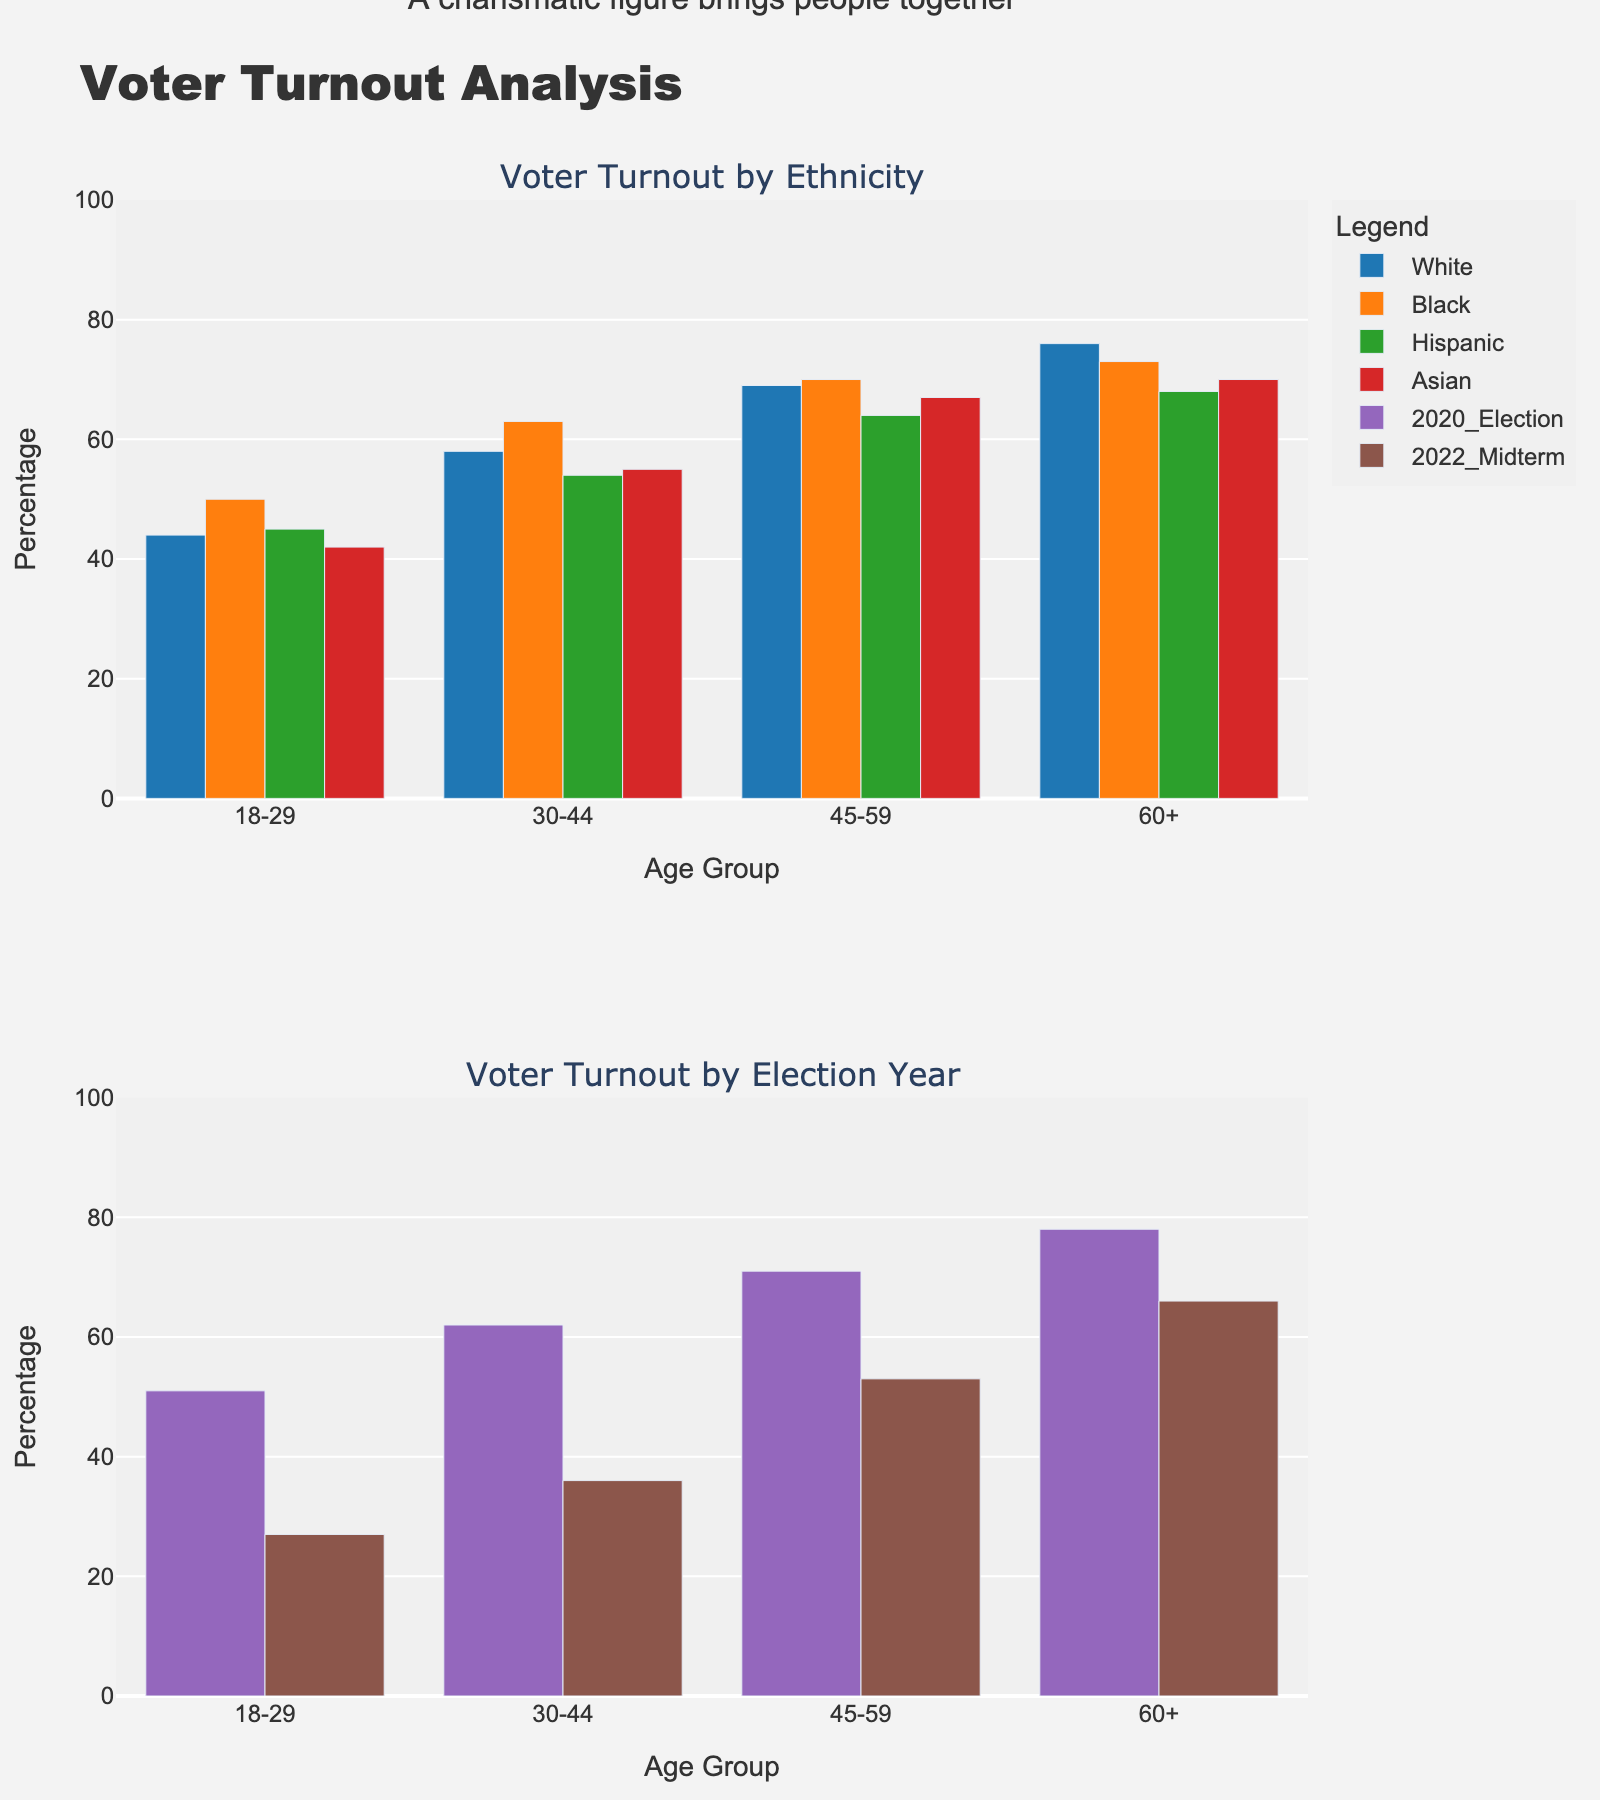Which age group has the highest voter turnout in the 2020 election? In the subplot comparing voter turnout by election year, the age group 60+ has the highest bar for the 2020 election. This indicates that the 60+ age group had the highest voter turnout.
Answer: 60+ Which ethnicity had the lowest voter turnout in the 18-29 age group? In the subplot comparing voter turnout by ethnicity, the shortest bar for the 18-29 age group corresponds to the Asian ethnicity. This indicates that the Asian ethnicity had the lowest voter turnout in this age group.
Answer: Asian What is the difference in voter turnout between the 2020 election and the 2022 midterm for the age group 30-44? In the subplot for voter turnout by election year, the 30-44 age group has a voter turnout of 62% in the 2020 election and 36% in the 2022 midterm. The difference is calculated as 62% - 36% = 26%.
Answer: 26% Which ethnicity has the most consistent voter turnout across all age groups? To determine consistency, we compare the heights of the bars for each ethnicity across all age groups in the top subplot. The Black ethnicity has bars that are relatively uniform in height across all age groups, unlike other ethnicities.
Answer: Black Among the 60+ age group, which election year had a higher voter turnout? In the subplot for voter turnout by election year, the height of the bar for the 60+ age group is higher for the 2020 election than the 2022 midterm, indicating a higher voter turnout in 2020.
Answer: 2020 election Compare the voter turnout of the 45-59 age group between Hispanics and Asians. In the subplot comparing voter turnout by ethnicity, for the age group 45-59, the bar for Asians is slightly higher than that for Hispanics. This indicates that Asians in the 45-59 age group had a higher voter turnout compared to Hispanics.
Answer: Asians What is the average voter turnout for the 18-29 age group across all ethnicities? To find the average, we add the voter turnout percentages for all ethnicities in the 18-29 age group and divide by the number of ethnicities. (44% + 50% + 45% + 42%) / 4 = 45.25%.
Answer: 45.25% Which age group showed the largest decrease in voter turnout from the 2020 election to the 2022 midterm? By comparing the heights of the bars for each age group between the 2020 election and 2022 midterm in the bottom subplot, the 18-29 age group shows the largest decrease in voter turnout.
Answer: 18-29 Which ethnicity had a voter turnout of 68% in the age group 60+? In the subplot for voter turnout by ethnicity, in the age group 60+, the bar for Hispanic ethnicity is at 68%.
Answer: Hispanic 